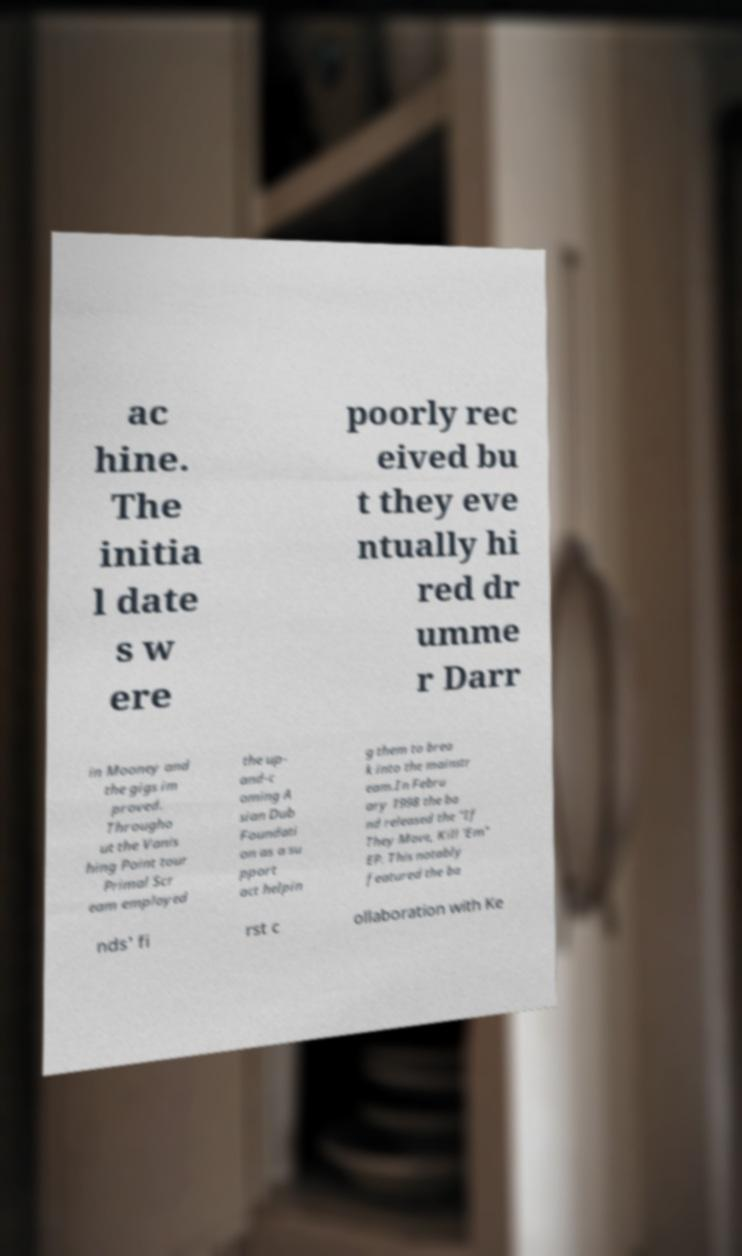Could you assist in decoding the text presented in this image and type it out clearly? ac hine. The initia l date s w ere poorly rec eived bu t they eve ntually hi red dr umme r Darr in Mooney and the gigs im proved. Througho ut the Vanis hing Point tour Primal Scr eam employed the up- and-c oming A sian Dub Foundati on as a su pport act helpin g them to brea k into the mainstr eam.In Febru ary 1998 the ba nd released the "If They Move, Kill 'Em" EP. This notably featured the ba nds' fi rst c ollaboration with Ke 